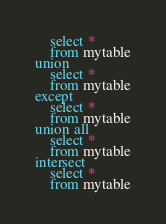Convert code to text. <code><loc_0><loc_0><loc_500><loc_500><_SQL_>    select *
    from mytable
union
    select *
    from mytable
except
    select *
    from mytable
union all
    select *
    from mytable
intersect
    select *
    from mytable</code> 